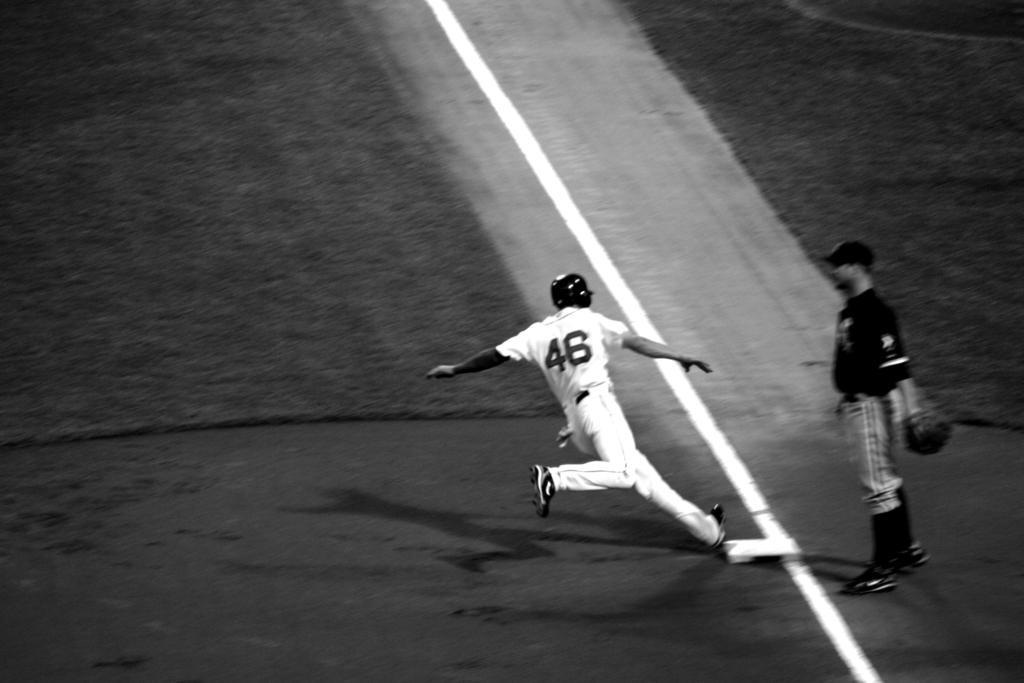Could you give a brief overview of what you see in this image? In this picture, we see a man in the white T-shirt is running. At the bottom, we see the pavement or the soil. In the left top, we see the grass. On the right side, we see a man in the black T-shirt is standing. In the right top, we see the grass. This is a black and white picture. This picture might be clicked in the playground. 